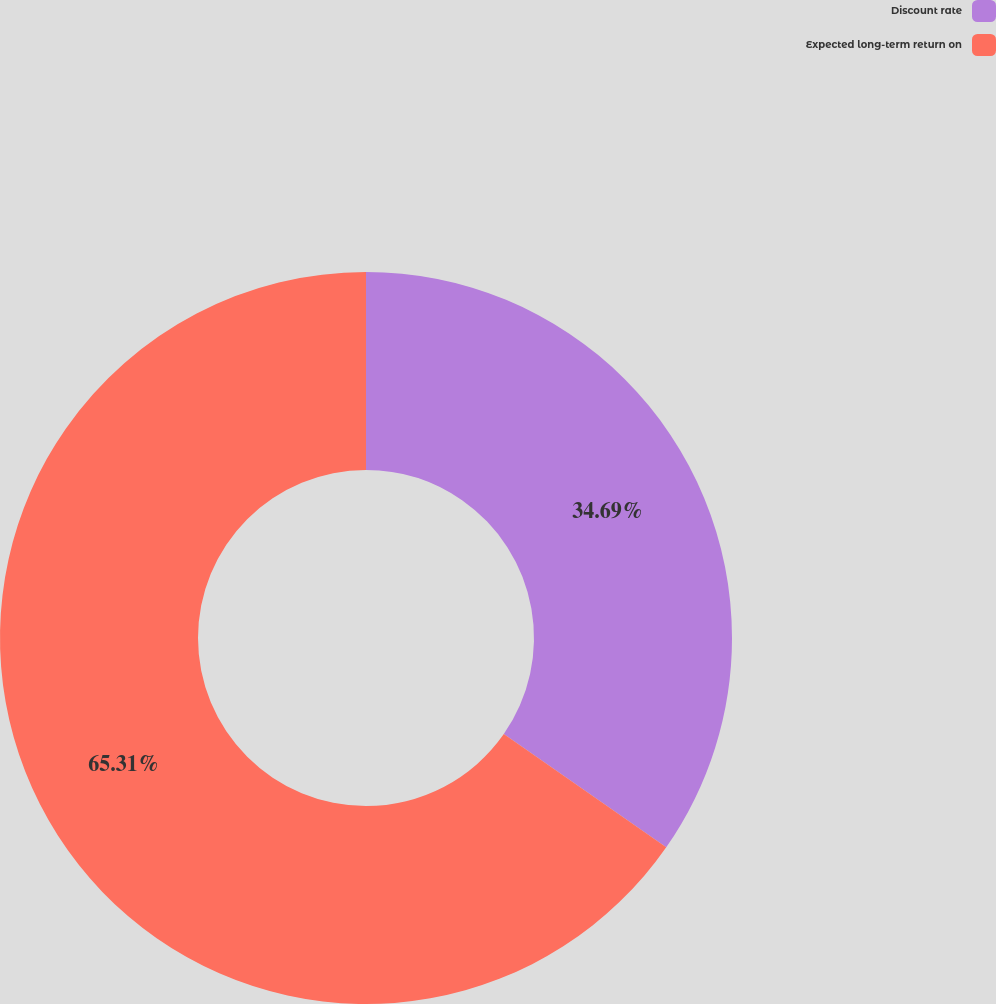Convert chart. <chart><loc_0><loc_0><loc_500><loc_500><pie_chart><fcel>Discount rate<fcel>Expected long-term return on<nl><fcel>34.69%<fcel>65.31%<nl></chart> 